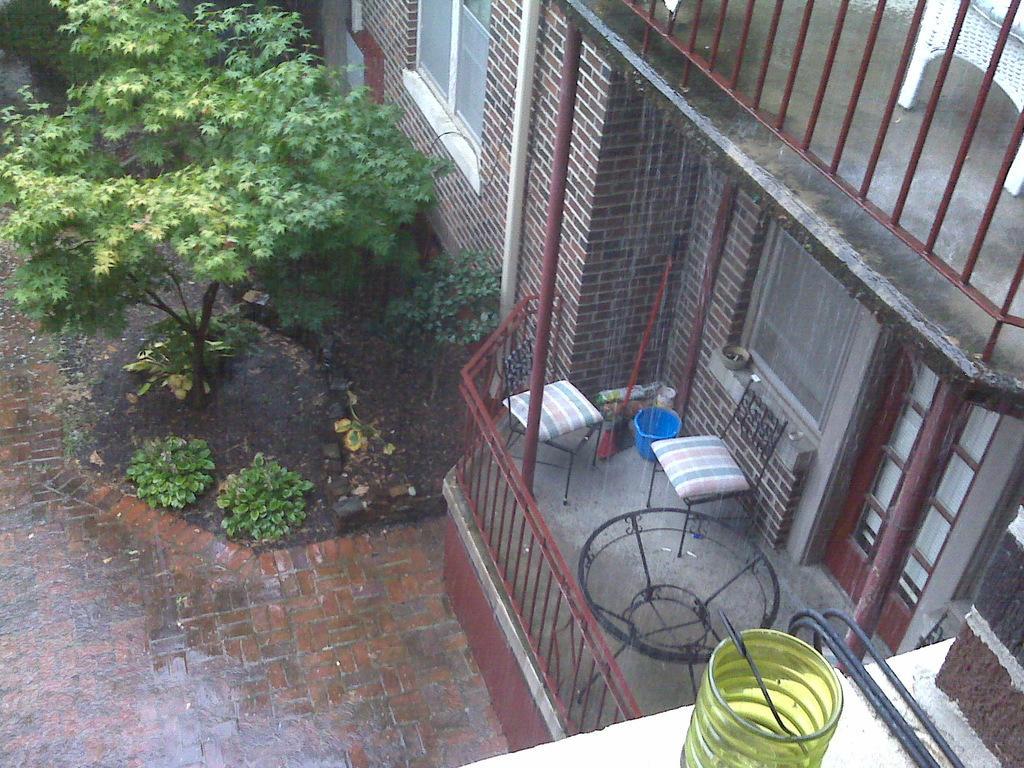How would you summarize this image in a sentence or two? In this image I can see a building, there is a table , bucket, chairs visible in the balcony of the building, and the building visible on the right side and there is a tree visible on the left side and there is a mug kept on bottom. 